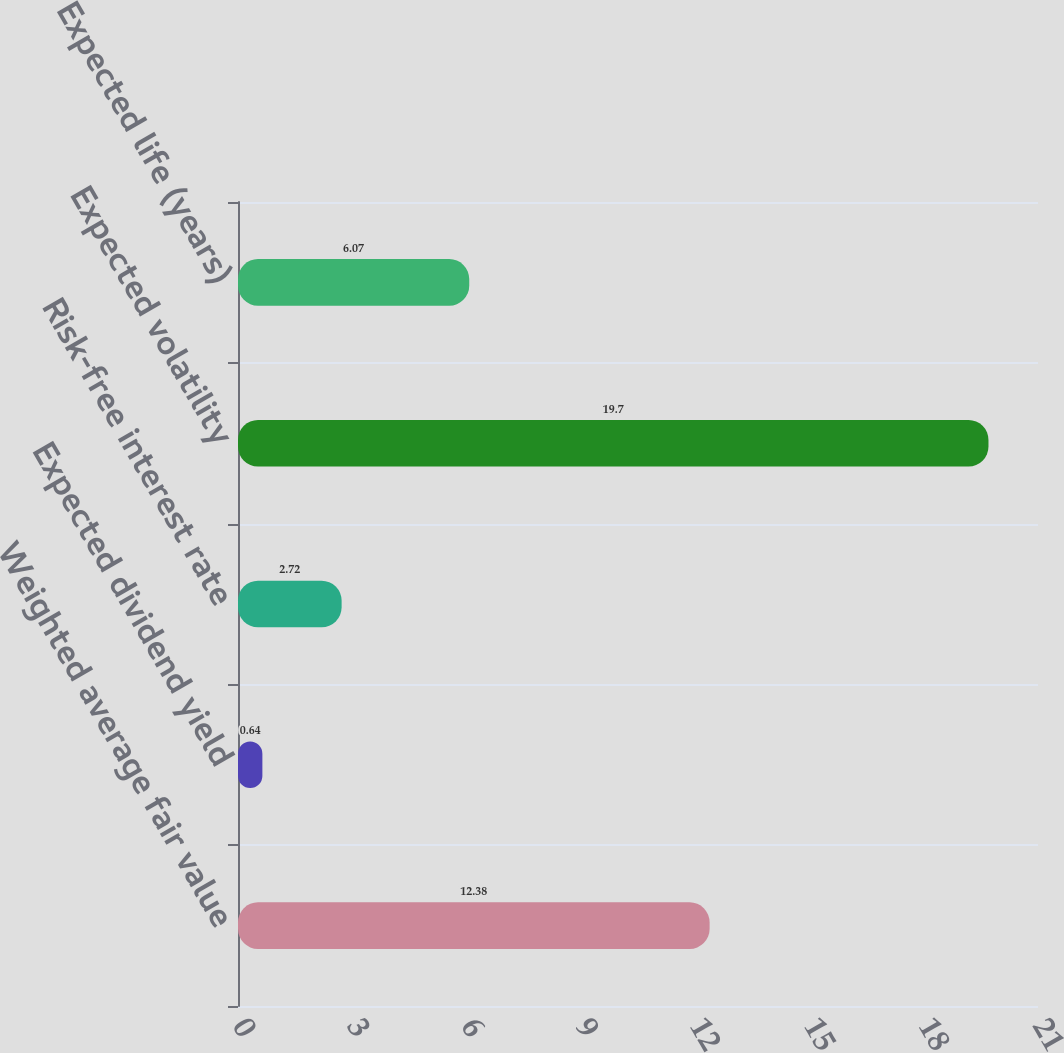Convert chart. <chart><loc_0><loc_0><loc_500><loc_500><bar_chart><fcel>Weighted average fair value<fcel>Expected dividend yield<fcel>Risk-free interest rate<fcel>Expected volatility<fcel>Expected life (years)<nl><fcel>12.38<fcel>0.64<fcel>2.72<fcel>19.7<fcel>6.07<nl></chart> 